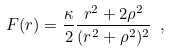<formula> <loc_0><loc_0><loc_500><loc_500>F ( r ) = \frac { \kappa } { 2 } \frac { r ^ { 2 } + 2 \rho ^ { 2 } } { ( r ^ { 2 } + \rho ^ { 2 } ) ^ { 2 } } \ ,</formula> 